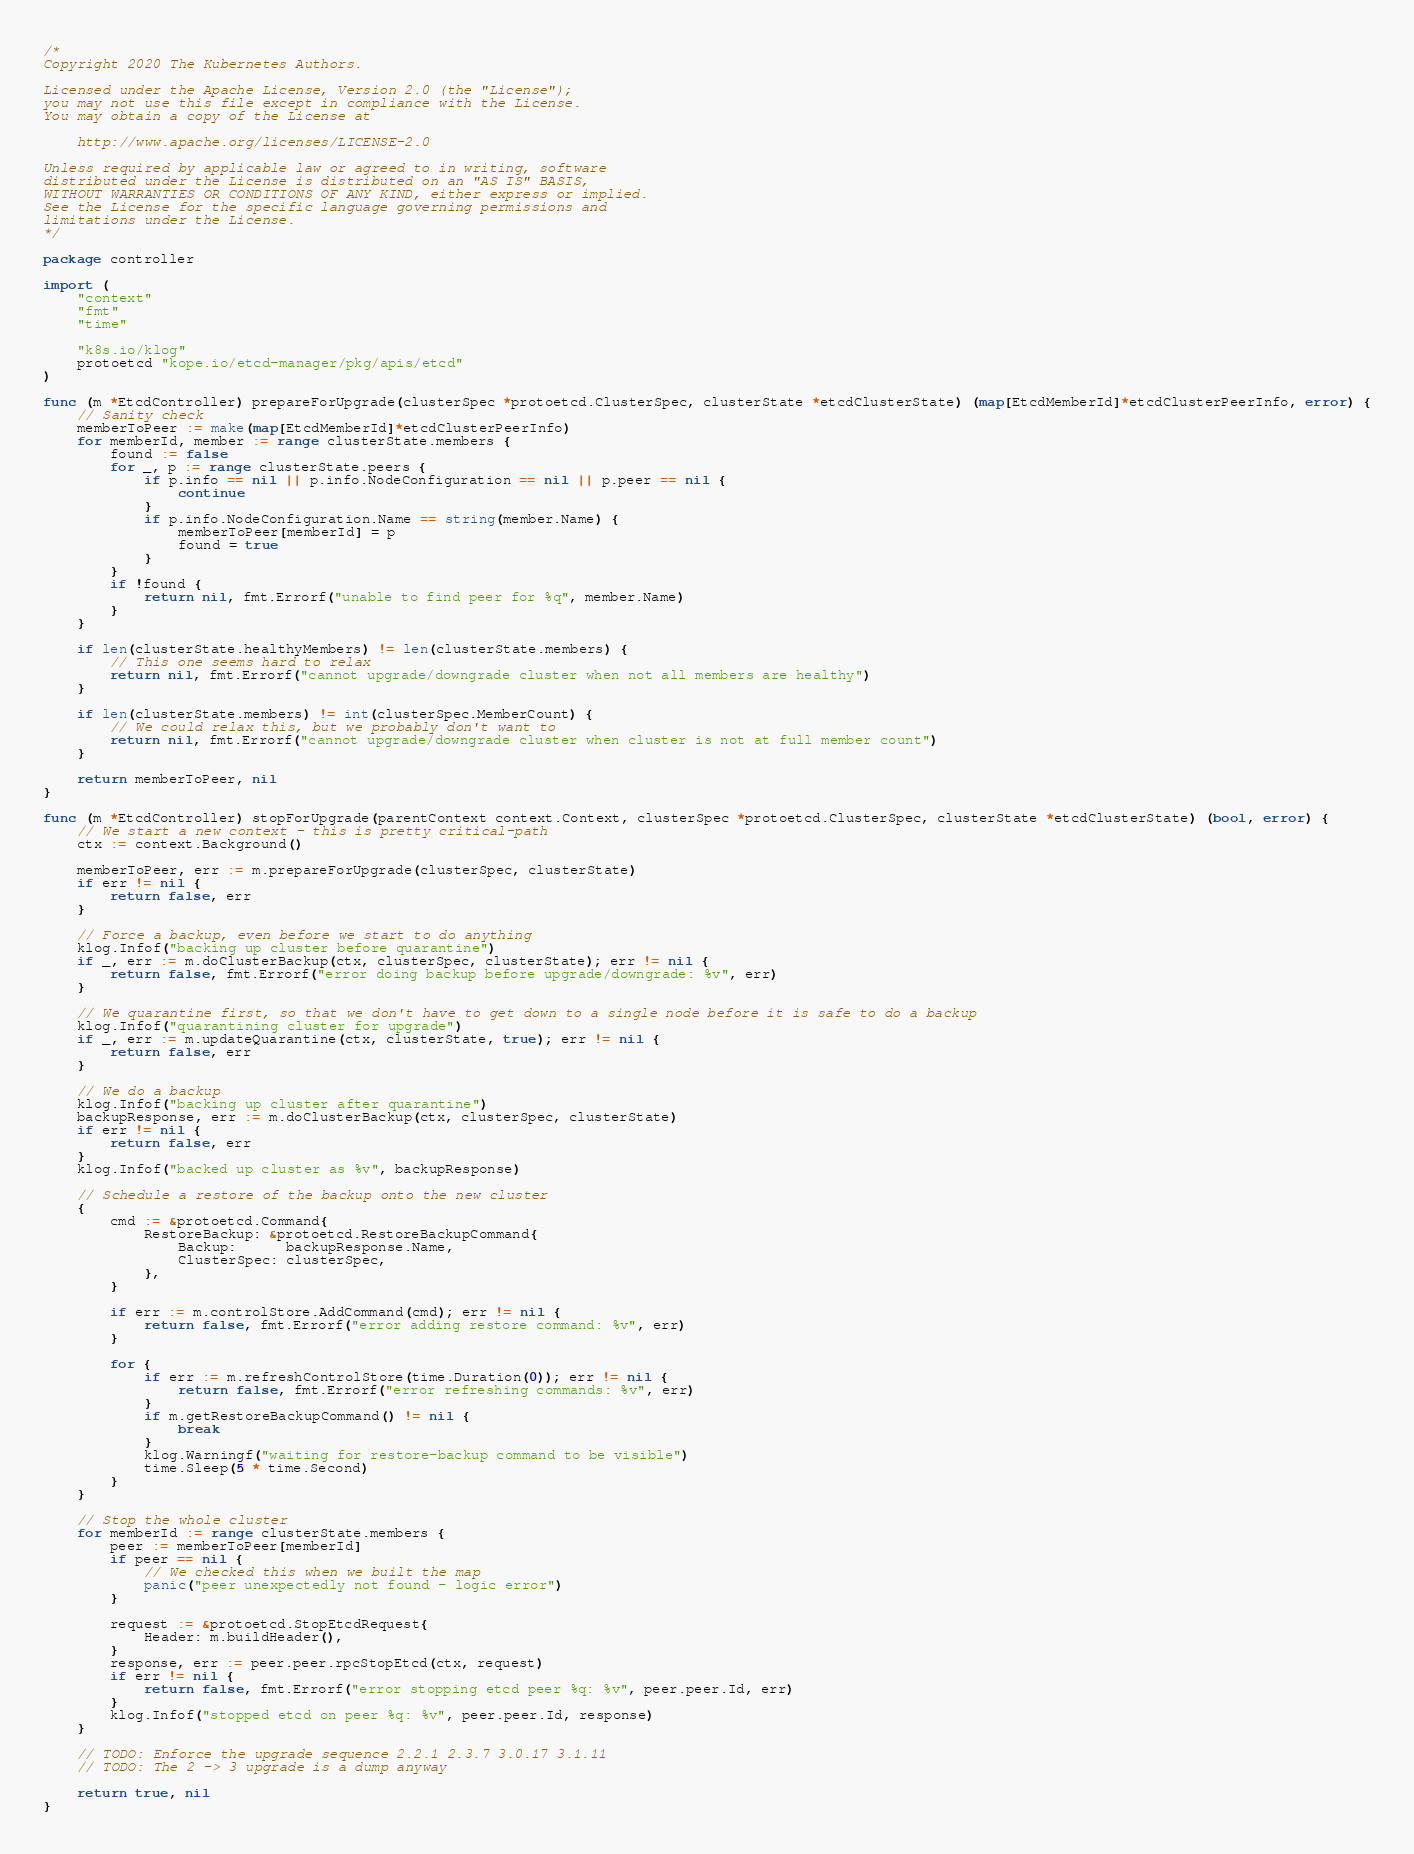Convert code to text. <code><loc_0><loc_0><loc_500><loc_500><_Go_>/*
Copyright 2020 The Kubernetes Authors.

Licensed under the Apache License, Version 2.0 (the "License");
you may not use this file except in compliance with the License.
You may obtain a copy of the License at

    http://www.apache.org/licenses/LICENSE-2.0

Unless required by applicable law or agreed to in writing, software
distributed under the License is distributed on an "AS IS" BASIS,
WITHOUT WARRANTIES OR CONDITIONS OF ANY KIND, either express or implied.
See the License for the specific language governing permissions and
limitations under the License.
*/

package controller

import (
	"context"
	"fmt"
	"time"

	"k8s.io/klog"
	protoetcd "kope.io/etcd-manager/pkg/apis/etcd"
)

func (m *EtcdController) prepareForUpgrade(clusterSpec *protoetcd.ClusterSpec, clusterState *etcdClusterState) (map[EtcdMemberId]*etcdClusterPeerInfo, error) {
	// Sanity check
	memberToPeer := make(map[EtcdMemberId]*etcdClusterPeerInfo)
	for memberId, member := range clusterState.members {
		found := false
		for _, p := range clusterState.peers {
			if p.info == nil || p.info.NodeConfiguration == nil || p.peer == nil {
				continue
			}
			if p.info.NodeConfiguration.Name == string(member.Name) {
				memberToPeer[memberId] = p
				found = true
			}
		}
		if !found {
			return nil, fmt.Errorf("unable to find peer for %q", member.Name)
		}
	}

	if len(clusterState.healthyMembers) != len(clusterState.members) {
		// This one seems hard to relax
		return nil, fmt.Errorf("cannot upgrade/downgrade cluster when not all members are healthy")
	}

	if len(clusterState.members) != int(clusterSpec.MemberCount) {
		// We could relax this, but we probably don't want to
		return nil, fmt.Errorf("cannot upgrade/downgrade cluster when cluster is not at full member count")
	}

	return memberToPeer, nil
}

func (m *EtcdController) stopForUpgrade(parentContext context.Context, clusterSpec *protoetcd.ClusterSpec, clusterState *etcdClusterState) (bool, error) {
	// We start a new context - this is pretty critical-path
	ctx := context.Background()

	memberToPeer, err := m.prepareForUpgrade(clusterSpec, clusterState)
	if err != nil {
		return false, err
	}

	// Force a backup, even before we start to do anything
	klog.Infof("backing up cluster before quarantine")
	if _, err := m.doClusterBackup(ctx, clusterSpec, clusterState); err != nil {
		return false, fmt.Errorf("error doing backup before upgrade/downgrade: %v", err)
	}

	// We quarantine first, so that we don't have to get down to a single node before it is safe to do a backup
	klog.Infof("quarantining cluster for upgrade")
	if _, err := m.updateQuarantine(ctx, clusterState, true); err != nil {
		return false, err
	}

	// We do a backup
	klog.Infof("backing up cluster after quarantine")
	backupResponse, err := m.doClusterBackup(ctx, clusterSpec, clusterState)
	if err != nil {
		return false, err
	}
	klog.Infof("backed up cluster as %v", backupResponse)

	// Schedule a restore of the backup onto the new cluster
	{
		cmd := &protoetcd.Command{
			RestoreBackup: &protoetcd.RestoreBackupCommand{
				Backup:      backupResponse.Name,
				ClusterSpec: clusterSpec,
			},
		}

		if err := m.controlStore.AddCommand(cmd); err != nil {
			return false, fmt.Errorf("error adding restore command: %v", err)
		}

		for {
			if err := m.refreshControlStore(time.Duration(0)); err != nil {
				return false, fmt.Errorf("error refreshing commands: %v", err)
			}
			if m.getRestoreBackupCommand() != nil {
				break
			}
			klog.Warningf("waiting for restore-backup command to be visible")
			time.Sleep(5 * time.Second)
		}
	}

	// Stop the whole cluster
	for memberId := range clusterState.members {
		peer := memberToPeer[memberId]
		if peer == nil {
			// We checked this when we built the map
			panic("peer unexpectedly not found - logic error")
		}

		request := &protoetcd.StopEtcdRequest{
			Header: m.buildHeader(),
		}
		response, err := peer.peer.rpcStopEtcd(ctx, request)
		if err != nil {
			return false, fmt.Errorf("error stopping etcd peer %q: %v", peer.peer.Id, err)
		}
		klog.Infof("stopped etcd on peer %q: %v", peer.peer.Id, response)
	}

	// TODO: Enforce the upgrade sequence 2.2.1 2.3.7 3.0.17 3.1.11
	// TODO: The 2 -> 3 upgrade is a dump anyway

	return true, nil
}
</code> 